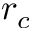Convert formula to latex. <formula><loc_0><loc_0><loc_500><loc_500>r _ { c }</formula> 